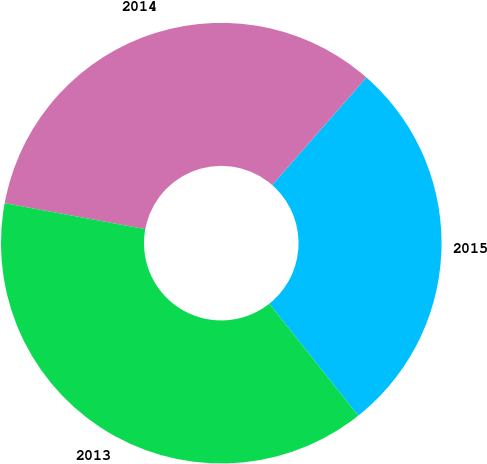Convert chart. <chart><loc_0><loc_0><loc_500><loc_500><pie_chart><fcel>2015<fcel>2014<fcel>2013<nl><fcel>27.87%<fcel>33.54%<fcel>38.58%<nl></chart> 